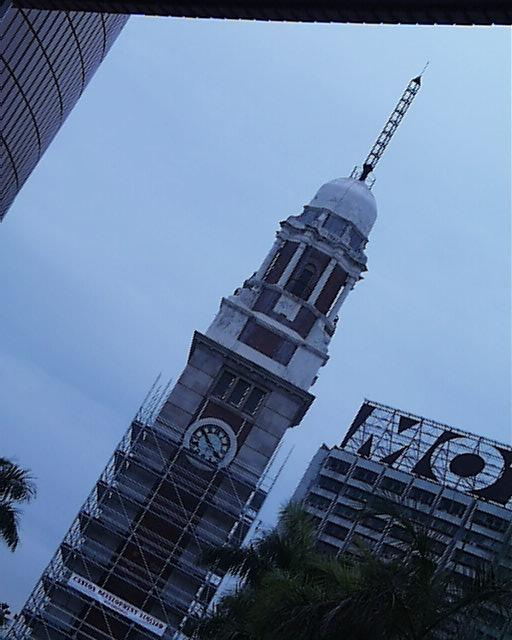Read all the text in this image. MO 